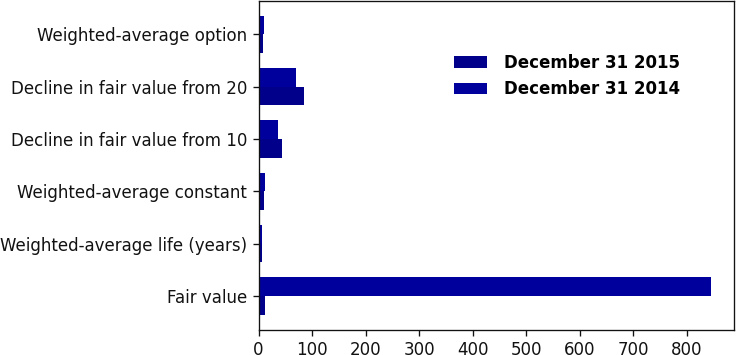<chart> <loc_0><loc_0><loc_500><loc_500><stacked_bar_chart><ecel><fcel>Fair value<fcel>Weighted-average life (years)<fcel>Weighted-average constant<fcel>Decline in fair value from 10<fcel>Decline in fair value from 20<fcel>Weighted-average option<nl><fcel>December 31 2015<fcel>11.16<fcel>6.3<fcel>10.61<fcel>44<fcel>85<fcel>8.93<nl><fcel>December 31 2014<fcel>845<fcel>6.1<fcel>11.16<fcel>36<fcel>69<fcel>10.36<nl></chart> 